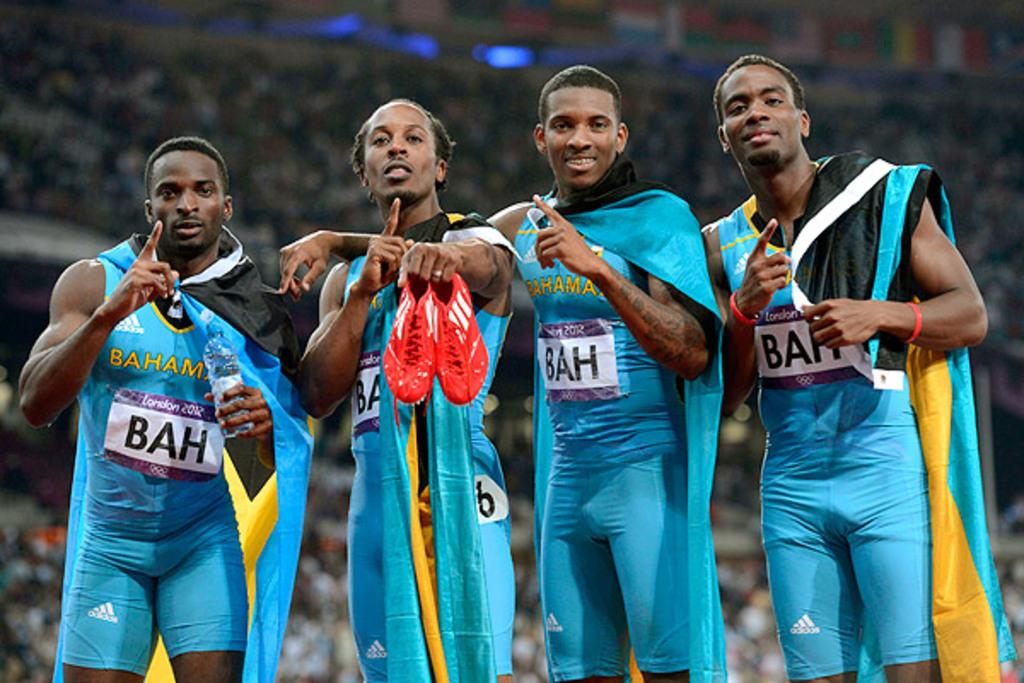<image>
Summarize the visual content of the image. a few players with the letters BAH on them 